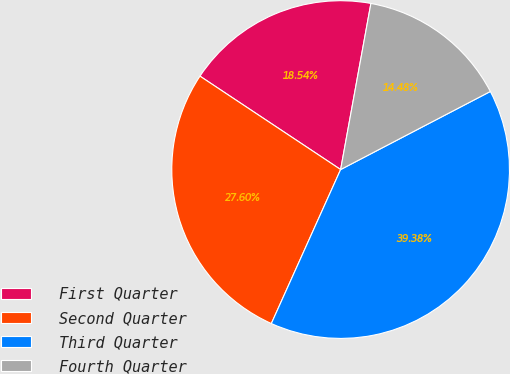<chart> <loc_0><loc_0><loc_500><loc_500><pie_chart><fcel>First Quarter<fcel>Second Quarter<fcel>Third Quarter<fcel>Fourth Quarter<nl><fcel>18.54%<fcel>27.6%<fcel>39.38%<fcel>14.48%<nl></chart> 